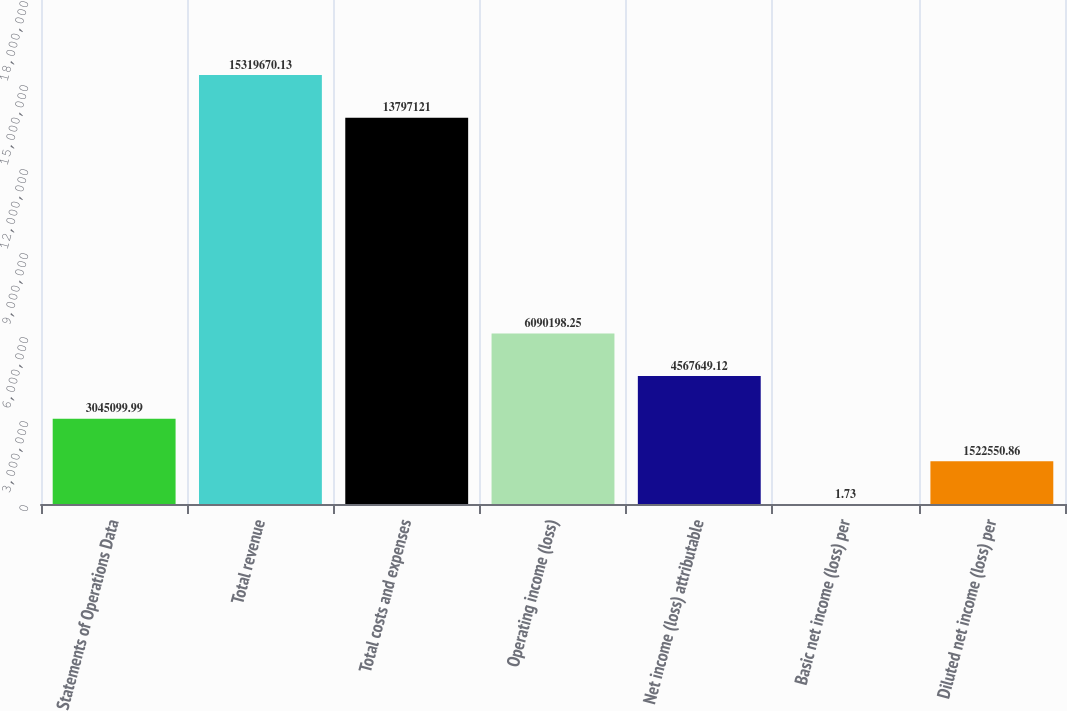Convert chart to OTSL. <chart><loc_0><loc_0><loc_500><loc_500><bar_chart><fcel>Statements of Operations Data<fcel>Total revenue<fcel>Total costs and expenses<fcel>Operating income (loss)<fcel>Net income (loss) attributable<fcel>Basic net income (loss) per<fcel>Diluted net income (loss) per<nl><fcel>3.0451e+06<fcel>1.53197e+07<fcel>1.37971e+07<fcel>6.0902e+06<fcel>4.56765e+06<fcel>1.73<fcel>1.52255e+06<nl></chart> 